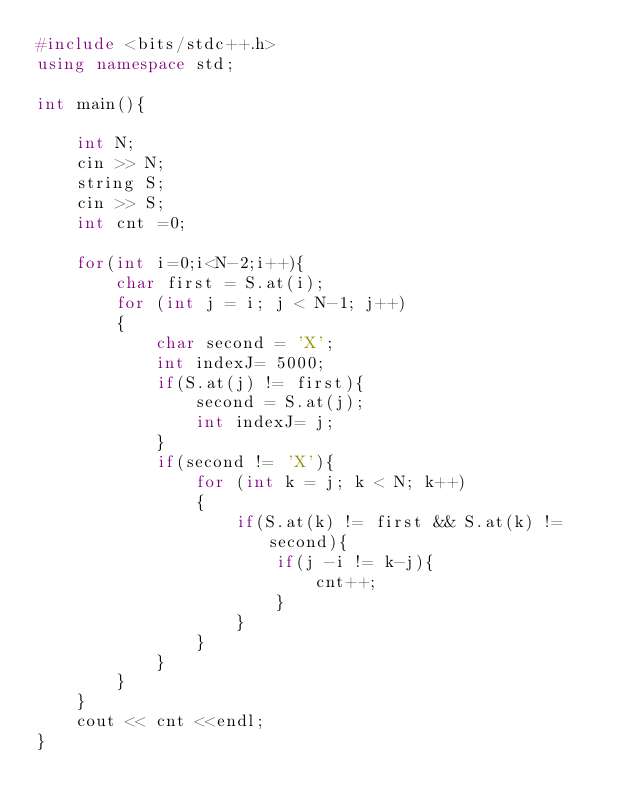<code> <loc_0><loc_0><loc_500><loc_500><_C++_>#include <bits/stdc++.h>
using namespace std;

int main(){

    int N;
    cin >> N;
    string S;
    cin >> S;
    int cnt =0;

    for(int i=0;i<N-2;i++){
        char first = S.at(i);
        for (int j = i; j < N-1; j++)
        {
            char second = 'X';
            int indexJ= 5000;
            if(S.at(j) != first){
                second = S.at(j);
                int indexJ= j;
            }
            if(second != 'X'){
                for (int k = j; k < N; k++)
                {
                    if(S.at(k) != first && S.at(k) != second){
                        if(j -i != k-j){
                            cnt++;
                        }
                    }
                }
            }
        }
    }
    cout << cnt <<endl;
}
</code> 